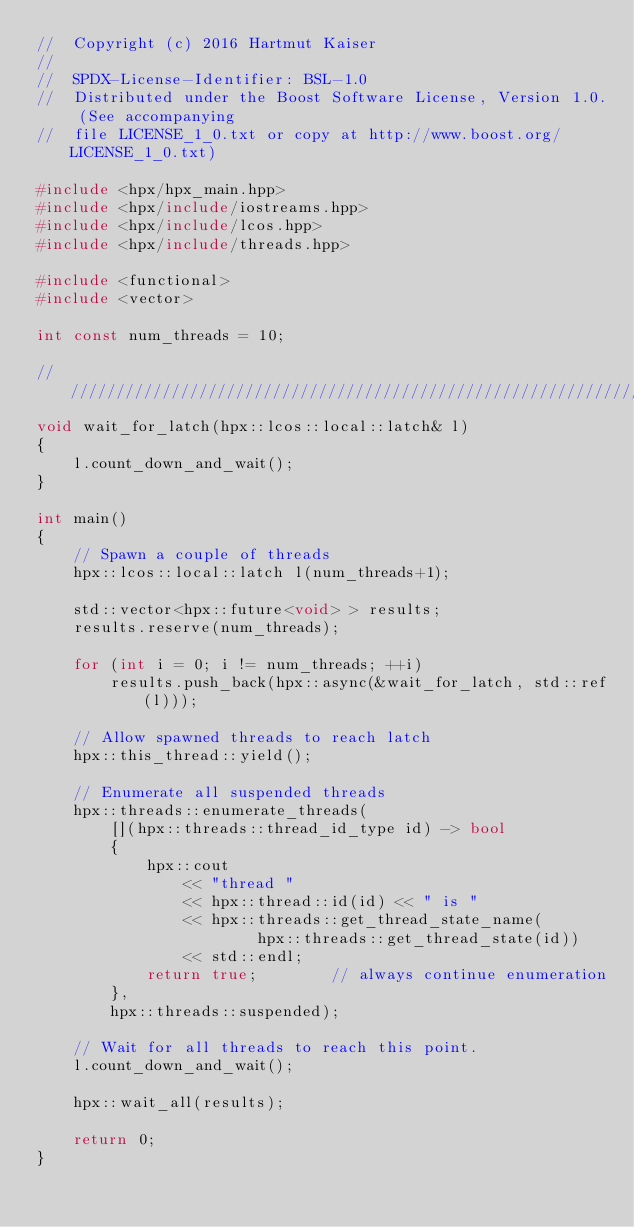Convert code to text. <code><loc_0><loc_0><loc_500><loc_500><_C++_>//  Copyright (c) 2016 Hartmut Kaiser
//
//  SPDX-License-Identifier: BSL-1.0
//  Distributed under the Boost Software License, Version 1.0. (See accompanying
//  file LICENSE_1_0.txt or copy at http://www.boost.org/LICENSE_1_0.txt)

#include <hpx/hpx_main.hpp>
#include <hpx/include/iostreams.hpp>
#include <hpx/include/lcos.hpp>
#include <hpx/include/threads.hpp>

#include <functional>
#include <vector>

int const num_threads = 10;

///////////////////////////////////////////////////////////////////////////////
void wait_for_latch(hpx::lcos::local::latch& l)
{
    l.count_down_and_wait();
}

int main()
{
    // Spawn a couple of threads
    hpx::lcos::local::latch l(num_threads+1);

    std::vector<hpx::future<void> > results;
    results.reserve(num_threads);

    for (int i = 0; i != num_threads; ++i)
        results.push_back(hpx::async(&wait_for_latch, std::ref(l)));

    // Allow spawned threads to reach latch
    hpx::this_thread::yield();

    // Enumerate all suspended threads
    hpx::threads::enumerate_threads(
        [](hpx::threads::thread_id_type id) -> bool
        {
            hpx::cout
                << "thread "
                << hpx::thread::id(id) << " is "
                << hpx::threads::get_thread_state_name(
                        hpx::threads::get_thread_state(id))
                << std::endl;
            return true;        // always continue enumeration
        },
        hpx::threads::suspended);

    // Wait for all threads to reach this point.
    l.count_down_and_wait();

    hpx::wait_all(results);

    return 0;
}


</code> 